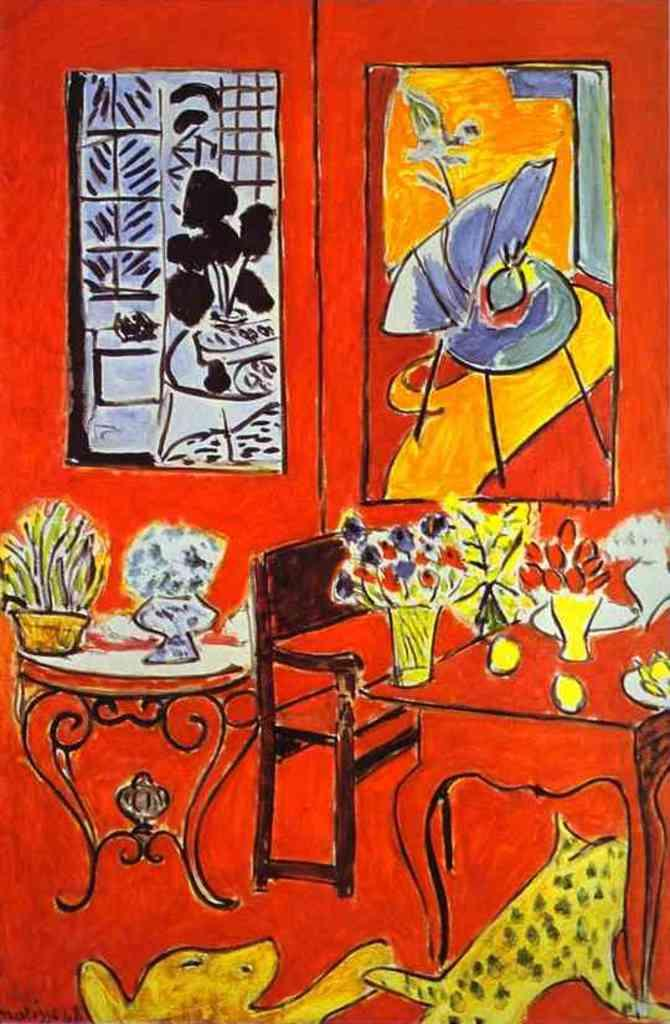What is the main subject of the painting in the image? The painting contains a scene with tables. What decorative elements are included in the painting? The painting includes vases with flowers and photo frames on the wall. What type of furniture is present in the painting? There is a bench in the painting. Are there any living creatures depicted in the painting? Yes, the painting features animals. What type of seed is being planted by the actor in the painting? There is no actor or seed present in the painting; it features a scene with tables, vases with flowers, a bench, and animals. 